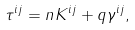Convert formula to latex. <formula><loc_0><loc_0><loc_500><loc_500>\tau ^ { i j } = n K ^ { i j } + q \gamma ^ { i j } ,</formula> 